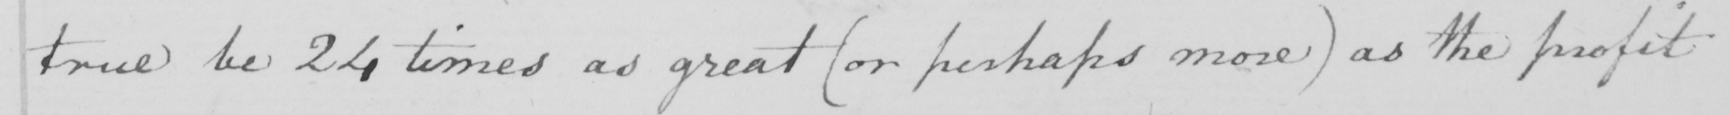What text is written in this handwritten line? true be 24 times as great (or perhaps more) as the profit 